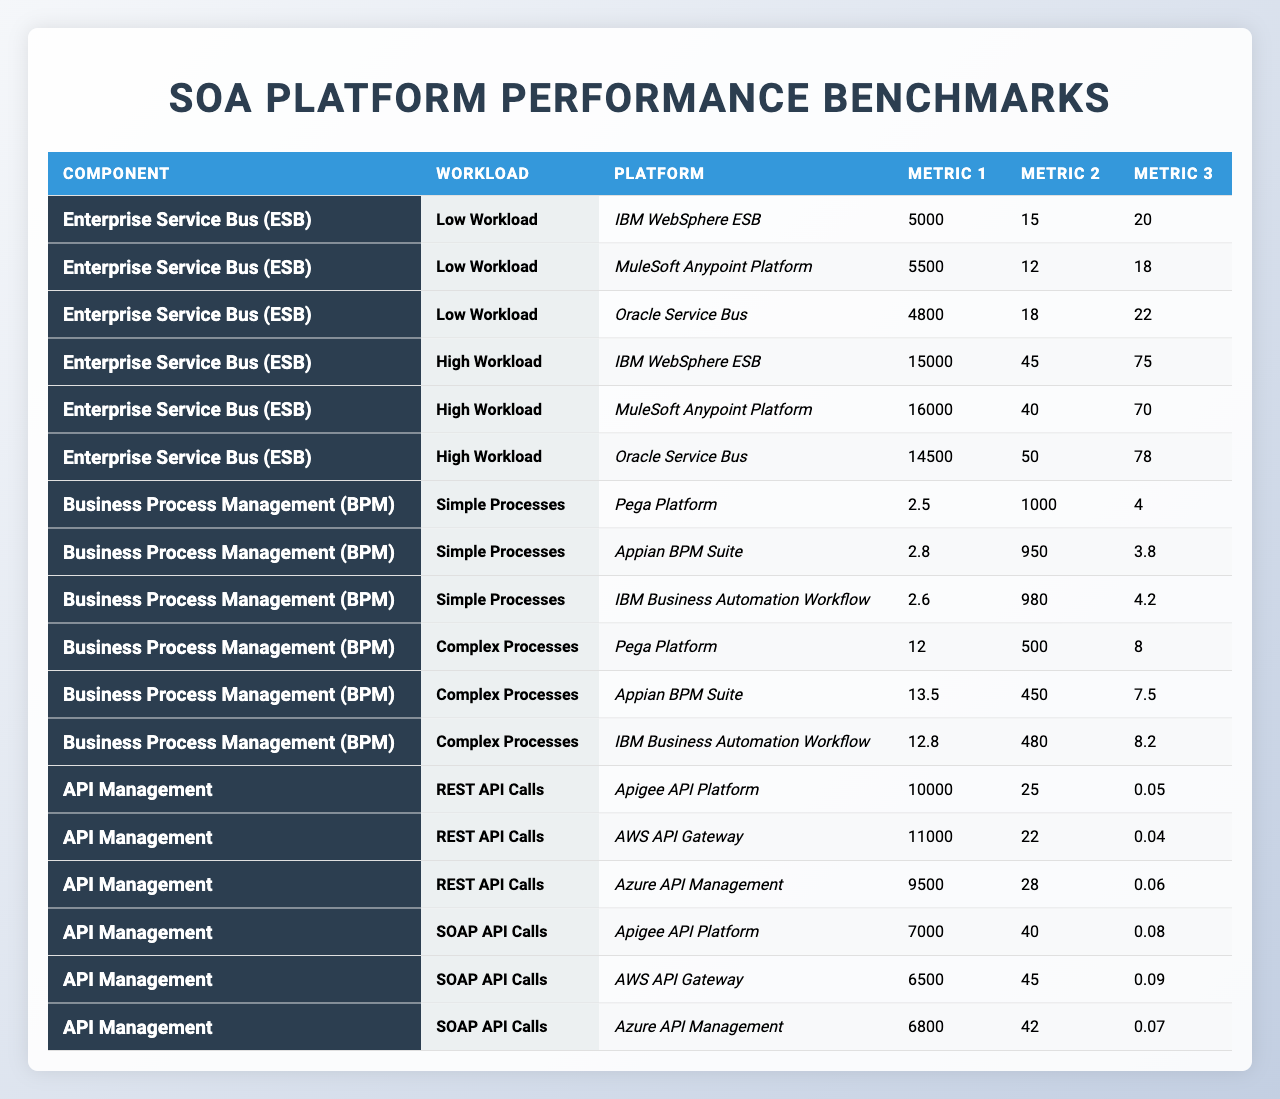What is the throughput of MuleSoft Anypoint Platform under high workload? The table shows that under high workload, MuleSoft Anypoint Platform has a throughput of 16000 messages per second.
Answer: 16000 msgs/sec Which SOA platform has the lowest latency in a low workload scenario? In the low workload category, MuleSoft Anypoint Platform has the lowest latency at 12 ms compared to the others, with IBM WebSphere ESB at 15 ms and Oracle Service Bus at 18 ms.
Answer: MuleSoft Anypoint Platform What is the average CPU utilization for IBM WebSphere ESB under both workloads? For low workload, the CPU utilization is 20%, and for high workload, it is 75%. The average is (20 + 75) / 2 = 47.5%.
Answer: 47.5% Does the error rate for AWS API Gateway exceed 0.05% for REST API calls? The error rate for AWS API Gateway for REST API calls is 0.04%, which does not exceed 0.05%.
Answer: No Which BPM platform has the highest memory usage for complex processes? The table indicates that IBM Business Automation Workflow has the highest memory usage for complex processes at 8.2 GB, compared to Pega Platform at 8 GB and Appian BPM Suite at 7.5 GB.
Answer: IBM Business Automation Workflow Calculate the difference in requests per second between Apigee API Platform and Azure API Management for REST API calls. Apigee API Platform has 10000 requests per second, and Azure API Management has 9500 requests per second. The difference is 10000 - 9500 = 500 requests per second.
Answer: 500 requests/sec What is the maximum number of concurrent users supported by Appian BPM Suite for simple processes? The table shows that Appian BPM Suite supports up to 950 concurrent users for simple processes.
Answer: 950 For low workload, which platform has the highest CPU utilization among the SOA platforms? The table shows that Oracle Service Bus has the highest CPU utilization under low workload at 22%, while IBM WebSphere ESB is at 20% and MuleSoft Anypoint Platform is at 18%.
Answer: Oracle Service Bus Is the process completion time for Pega Platform longer for complex processes than for simple processes? The table shows that Pega Platform takes 12 seconds for complex processes and 2.5 seconds for simple processes, confirming that it is longer for complex processes.
Answer: Yes Identify the platform that offers the lowest memory usage for simple processes. For simple processes, Appian BPM Suite uses 3.8 GB, which is the lowest compared to Pega Platform at 4 GB and IBM Business Automation Workflow at 4.2 GB.
Answer: Appian BPM Suite What is the total throughput for both IBM WebSphere ESB workloads combined? For IBM WebSphere ESB, the throughput under low workload is 5000 msgs/sec and under high workload is 15000 msgs/sec. The total throughput is 5000 + 15000 = 20000 msgs/sec.
Answer: 20000 msgs/sec 